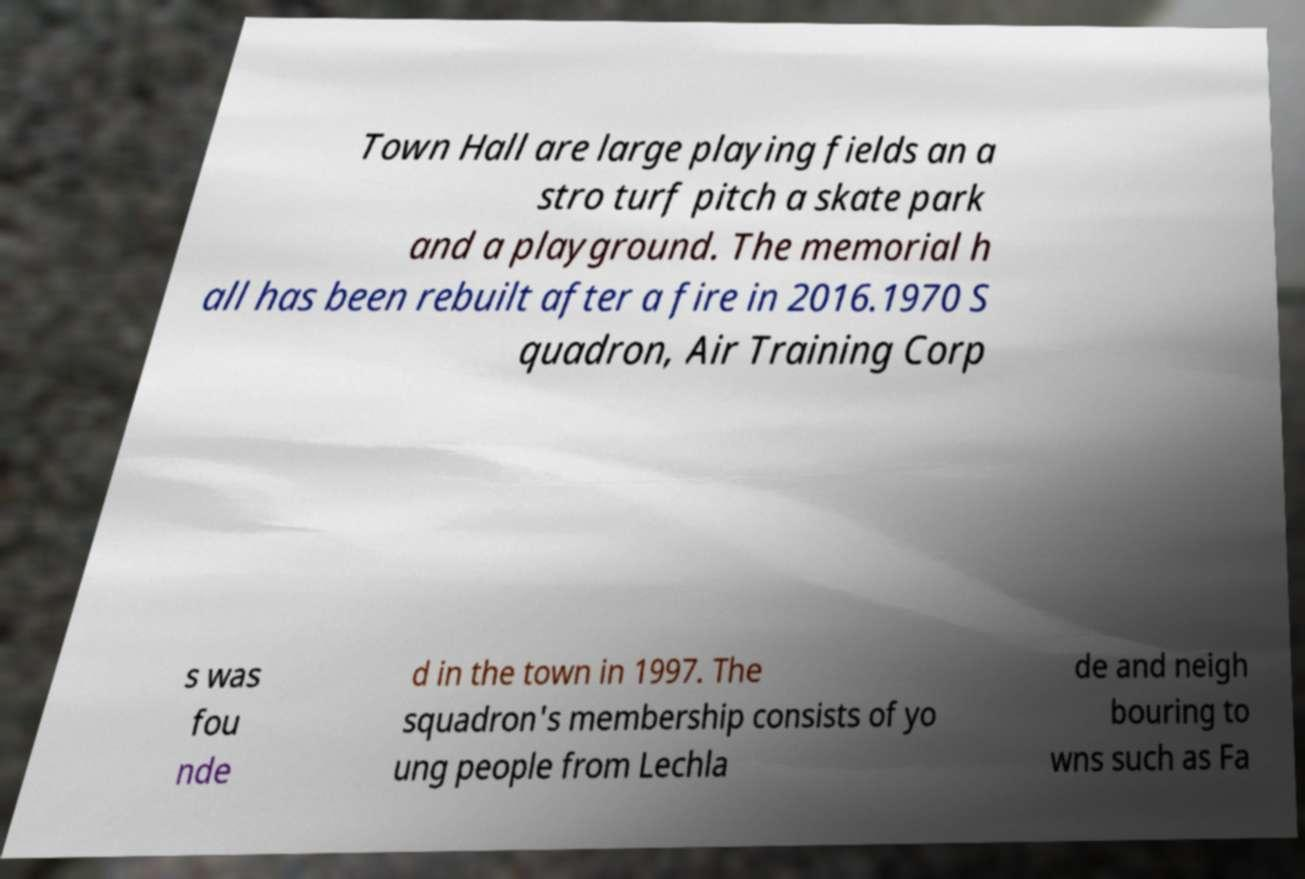For documentation purposes, I need the text within this image transcribed. Could you provide that? Town Hall are large playing fields an a stro turf pitch a skate park and a playground. The memorial h all has been rebuilt after a fire in 2016.1970 S quadron, Air Training Corp s was fou nde d in the town in 1997. The squadron's membership consists of yo ung people from Lechla de and neigh bouring to wns such as Fa 